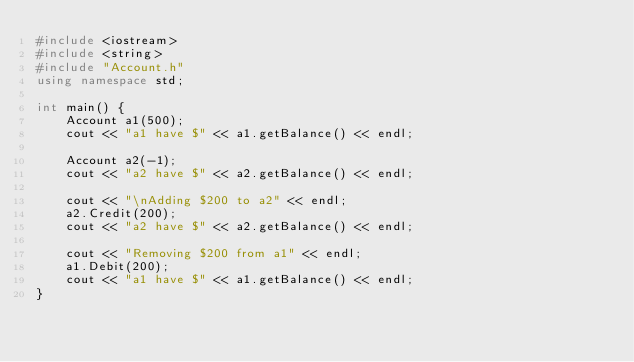Convert code to text. <code><loc_0><loc_0><loc_500><loc_500><_C++_>#include <iostream>
#include <string>  
#include "Account.h"
using namespace std;

int main() {
	Account a1(500);
	cout << "a1 have $" << a1.getBalance() << endl;

	Account a2(-1);
	cout << "a2 have $" << a2.getBalance() << endl;

	cout << "\nAdding $200 to a2" << endl;
	a2.Credit(200);
	cout << "a2 have $" << a2.getBalance() << endl;

	cout << "Removing $200 from a1" << endl;
	a1.Debit(200);
	cout << "a1 have $" << a1.getBalance() << endl;
}</code> 